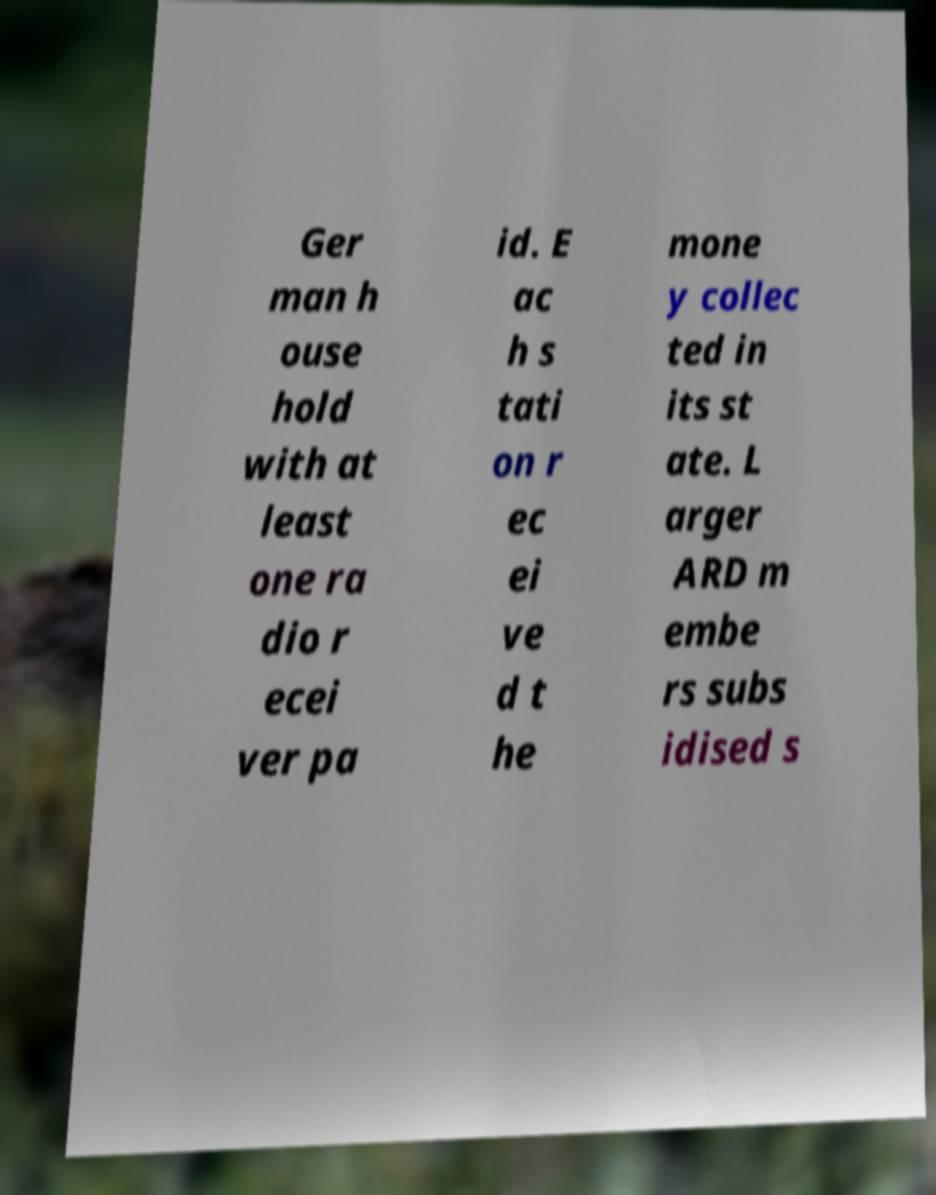Please identify and transcribe the text found in this image. Ger man h ouse hold with at least one ra dio r ecei ver pa id. E ac h s tati on r ec ei ve d t he mone y collec ted in its st ate. L arger ARD m embe rs subs idised s 